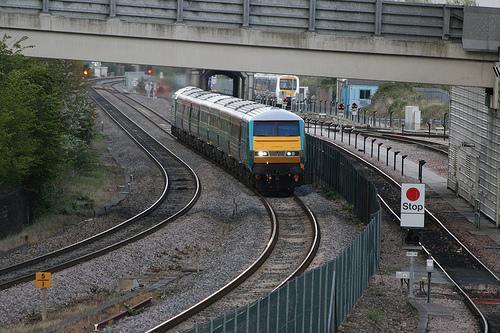How many trains are pictured here?
Give a very brief answer. 2. How many people appear in this photo?
Give a very brief answer. 0. 